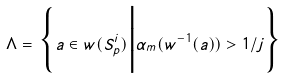<formula> <loc_0><loc_0><loc_500><loc_500>\Lambda = \Big \{ a \in w ( S _ { p } ^ { i } ) \Big | \alpha _ { m } ( w ^ { - 1 } ( a ) ) > 1 / j \Big \}</formula> 